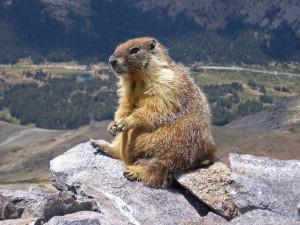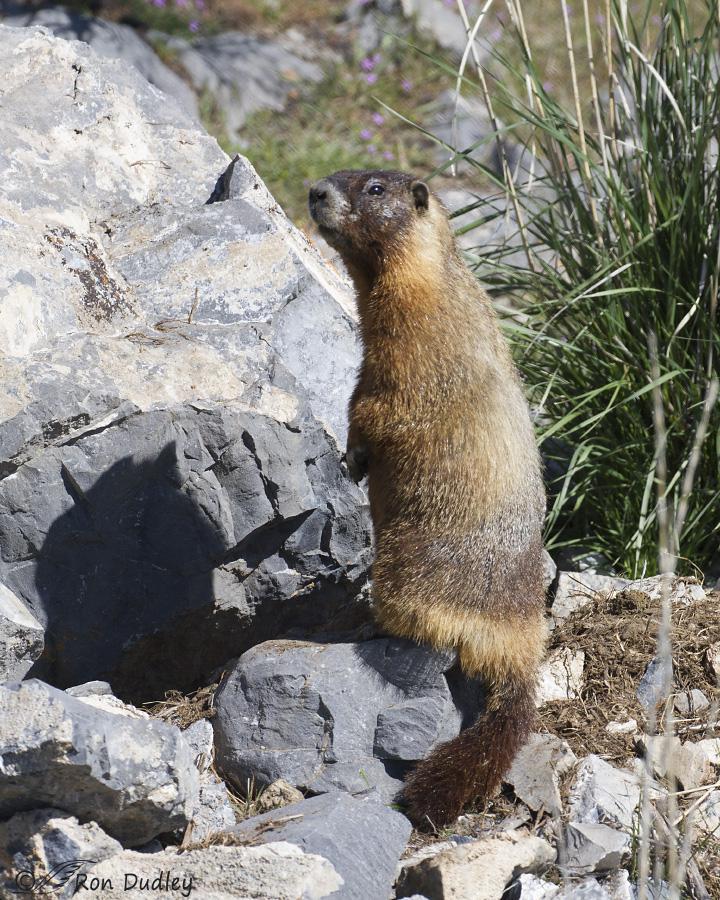The first image is the image on the left, the second image is the image on the right. Assess this claim about the two images: "Both marmots are facing toward the right". Correct or not? Answer yes or no. No. The first image is the image on the left, the second image is the image on the right. Given the left and right images, does the statement "Each image shows just one groundhog-type animal, which is facing rightward." hold true? Answer yes or no. No. 